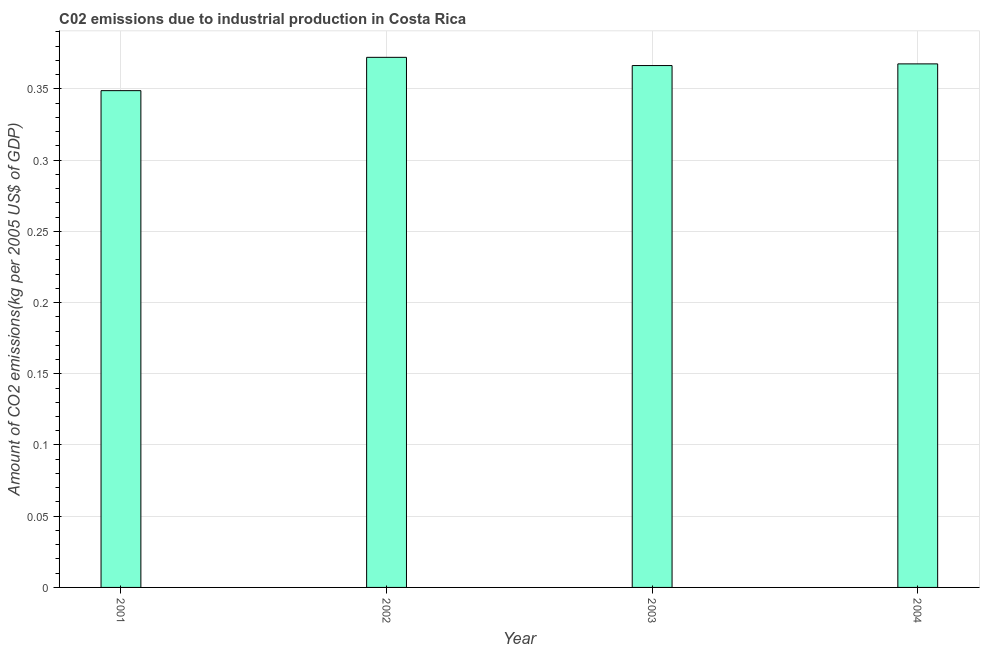Does the graph contain any zero values?
Your answer should be very brief. No. Does the graph contain grids?
Make the answer very short. Yes. What is the title of the graph?
Give a very brief answer. C02 emissions due to industrial production in Costa Rica. What is the label or title of the X-axis?
Make the answer very short. Year. What is the label or title of the Y-axis?
Keep it short and to the point. Amount of CO2 emissions(kg per 2005 US$ of GDP). What is the amount of co2 emissions in 2001?
Ensure brevity in your answer.  0.35. Across all years, what is the maximum amount of co2 emissions?
Provide a short and direct response. 0.37. Across all years, what is the minimum amount of co2 emissions?
Make the answer very short. 0.35. What is the sum of the amount of co2 emissions?
Keep it short and to the point. 1.45. What is the difference between the amount of co2 emissions in 2003 and 2004?
Ensure brevity in your answer.  -0. What is the average amount of co2 emissions per year?
Provide a succinct answer. 0.36. What is the median amount of co2 emissions?
Your response must be concise. 0.37. Do a majority of the years between 2002 and 2001 (inclusive) have amount of co2 emissions greater than 0.2 kg per 2005 US$ of GDP?
Offer a very short reply. No. Is the amount of co2 emissions in 2001 less than that in 2004?
Give a very brief answer. Yes. What is the difference between the highest and the second highest amount of co2 emissions?
Provide a succinct answer. 0.01. Is the sum of the amount of co2 emissions in 2003 and 2004 greater than the maximum amount of co2 emissions across all years?
Your answer should be compact. Yes. What is the difference between the highest and the lowest amount of co2 emissions?
Provide a succinct answer. 0.02. In how many years, is the amount of co2 emissions greater than the average amount of co2 emissions taken over all years?
Keep it short and to the point. 3. How many bars are there?
Your answer should be very brief. 4. Are all the bars in the graph horizontal?
Give a very brief answer. No. How many years are there in the graph?
Provide a succinct answer. 4. What is the Amount of CO2 emissions(kg per 2005 US$ of GDP) in 2001?
Give a very brief answer. 0.35. What is the Amount of CO2 emissions(kg per 2005 US$ of GDP) in 2002?
Offer a very short reply. 0.37. What is the Amount of CO2 emissions(kg per 2005 US$ of GDP) in 2003?
Provide a succinct answer. 0.37. What is the Amount of CO2 emissions(kg per 2005 US$ of GDP) in 2004?
Offer a terse response. 0.37. What is the difference between the Amount of CO2 emissions(kg per 2005 US$ of GDP) in 2001 and 2002?
Provide a short and direct response. -0.02. What is the difference between the Amount of CO2 emissions(kg per 2005 US$ of GDP) in 2001 and 2003?
Offer a very short reply. -0.02. What is the difference between the Amount of CO2 emissions(kg per 2005 US$ of GDP) in 2001 and 2004?
Your response must be concise. -0.02. What is the difference between the Amount of CO2 emissions(kg per 2005 US$ of GDP) in 2002 and 2003?
Your response must be concise. 0.01. What is the difference between the Amount of CO2 emissions(kg per 2005 US$ of GDP) in 2002 and 2004?
Provide a succinct answer. 0. What is the difference between the Amount of CO2 emissions(kg per 2005 US$ of GDP) in 2003 and 2004?
Offer a terse response. -0. What is the ratio of the Amount of CO2 emissions(kg per 2005 US$ of GDP) in 2001 to that in 2002?
Keep it short and to the point. 0.94. What is the ratio of the Amount of CO2 emissions(kg per 2005 US$ of GDP) in 2001 to that in 2004?
Your answer should be very brief. 0.95. 